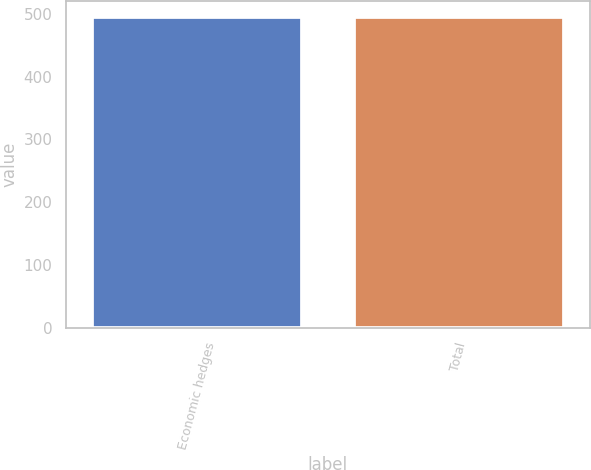Convert chart. <chart><loc_0><loc_0><loc_500><loc_500><bar_chart><fcel>Economic hedges<fcel>Total<nl><fcel>496<fcel>496.1<nl></chart> 